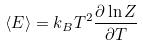Convert formula to latex. <formula><loc_0><loc_0><loc_500><loc_500>\langle E \rangle = k _ { B } T ^ { 2 } \frac { \partial \ln Z } { \partial T }</formula> 